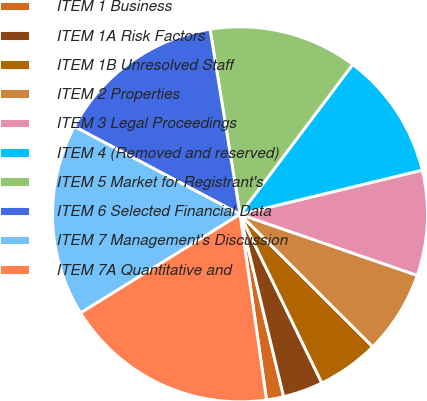<chart> <loc_0><loc_0><loc_500><loc_500><pie_chart><fcel>ITEM 1 Business<fcel>ITEM 1A Risk Factors<fcel>ITEM 1B Unresolved Staff<fcel>ITEM 2 Properties<fcel>ITEM 3 Legal Proceedings<fcel>ITEM 4 (Removed and reserved)<fcel>ITEM 5 Market for Registrant's<fcel>ITEM 6 Selected Financial Data<fcel>ITEM 7 Management's Discussion<fcel>ITEM 7A Quantitative and<nl><fcel>1.48%<fcel>3.45%<fcel>5.33%<fcel>7.2%<fcel>9.07%<fcel>10.95%<fcel>12.82%<fcel>14.69%<fcel>16.57%<fcel>18.44%<nl></chart> 